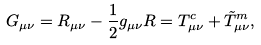<formula> <loc_0><loc_0><loc_500><loc_500>G _ { \mu \nu } = R _ { \mu \nu } - \frac { 1 } { 2 } g _ { \mu \nu } R = T _ { \mu \nu } ^ { c } + \tilde { T } _ { \mu \nu } ^ { m } ,</formula> 